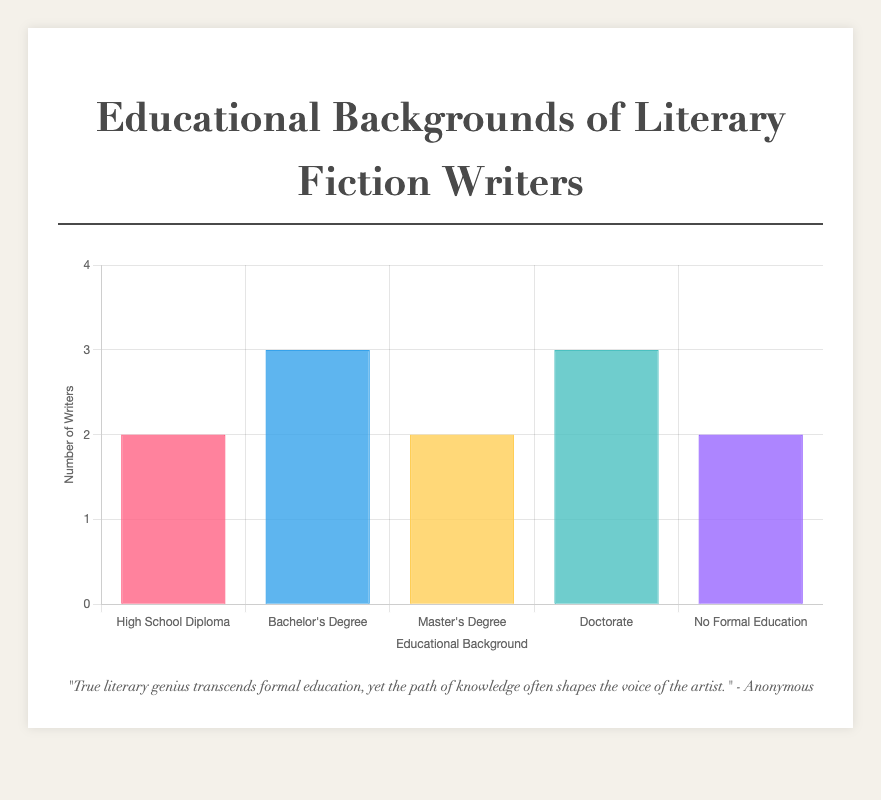Which educational background has the highest number of literary fiction writers? By examining the different degrees and their associated counts, we can see that Bachelor's Degree and Doctorate both have 3 writers each. Hence, these educational backgrounds have the highest number of writers.
Answer: Bachelor's Degree and Doctorate How many more literary fiction writers have a bachelor's degree compared to those with a high school diploma? There are 3 writers with a bachelor's degree and 2 writers with a high school diploma. The difference is 3 - 2 = 1. So, there is 1 more writer with a bachelor's degree compared to a high school diploma.
Answer: 1 What is the total number of literary fiction writers represented in the chart? Adding up all the writers from each degree: 2 (High School Diploma) + 3 (Bachelor's Degree) + 2 (Master's Degree) + 3 (Doctorate) + 2 (No Formal Education) = 12 literary fiction writers in total.
Answer: 12 Compare the number of literary fiction writers with Doctorate to those with no formal education. Which group is larger? To determine which group is larger, we compare the numbers directly: 3 writers with a Doctorate and 2 writers with no formal education. Hence, the Doctorate group is larger.
Answer: Doctorate How many literary fiction writers have at least a master's degree? The counts for writers with a master's degree and a doctorate are 2 and 3, respectively. Summing these amounts gives us 2 + 3 = 5. Therefore, there are 5 writers with at least a master's degree.
Answer: 5 Which educational background has the least number of literary fiction writers? By comparing all available counts, we see that High School Diploma and No Formal Education both have 2 writers. Hence, they are tied for the least number of writers.
Answer: High School Diploma and No Formal Education What is the average number of writers per educational category? Summing the total number of writers, which is 12, and dividing by the 5 categories yields an average of 12 / 5 = 2.4 writers per category.
Answer: 2.4 What is the proportion of writers with a doctorate out of the total writers? There are 3 writers with a doctorate out of a total of 12 writers. The proportion is 3/12 = 0.25 or 25%.
Answer: 25% Which category has equally balanced visual bars in the chart? Describe it. The High School Diploma, Master’s Degree, and No Formal Education categories all have equally tall bars, each representing 2 writers, visually balanced in their height.
Answer: High School Diploma, Master's Degree, No Formal Education Determine the percentage of writers with no formal education relative to the total writers. There are 2 writers with no formal education out of a total of 12 writers, which results in the percentage being (2/12) * 100 = 16.67%.
Answer: 16.67% 